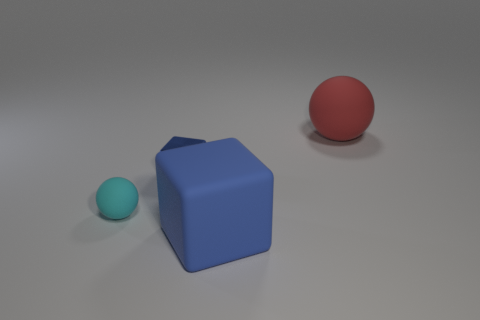Add 4 blue cubes. How many objects exist? 8 Subtract all red balls. Subtract all brown cylinders. How many balls are left? 1 Subtract all large matte objects. Subtract all tiny matte balls. How many objects are left? 1 Add 4 large red matte balls. How many large red matte balls are left? 5 Add 3 big matte cubes. How many big matte cubes exist? 4 Subtract 1 cyan spheres. How many objects are left? 3 